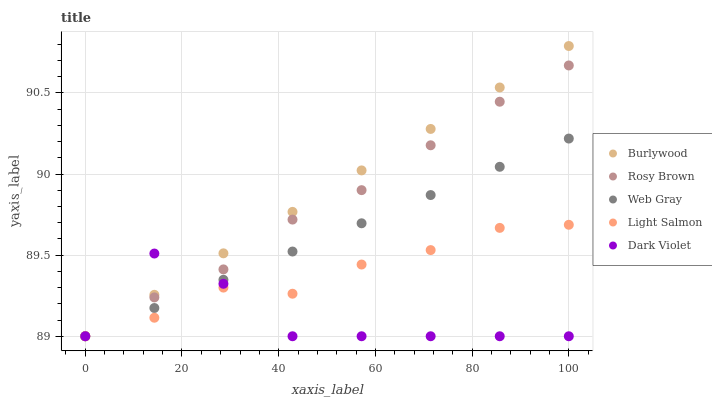Does Dark Violet have the minimum area under the curve?
Answer yes or no. Yes. Does Burlywood have the maximum area under the curve?
Answer yes or no. Yes. Does Light Salmon have the minimum area under the curve?
Answer yes or no. No. Does Light Salmon have the maximum area under the curve?
Answer yes or no. No. Is Web Gray the smoothest?
Answer yes or no. Yes. Is Dark Violet the roughest?
Answer yes or no. Yes. Is Light Salmon the smoothest?
Answer yes or no. No. Is Light Salmon the roughest?
Answer yes or no. No. Does Burlywood have the lowest value?
Answer yes or no. Yes. Does Burlywood have the highest value?
Answer yes or no. Yes. Does Light Salmon have the highest value?
Answer yes or no. No. Does Dark Violet intersect Burlywood?
Answer yes or no. Yes. Is Dark Violet less than Burlywood?
Answer yes or no. No. Is Dark Violet greater than Burlywood?
Answer yes or no. No. 